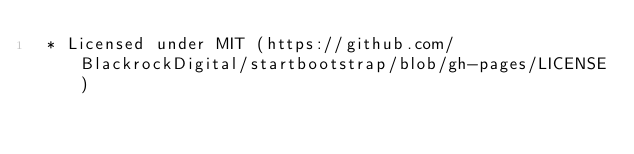<code> <loc_0><loc_0><loc_500><loc_500><_CSS_> * Licensed under MIT (https://github.com/BlackrockDigital/startbootstrap/blob/gh-pages/LICENSE)</code> 